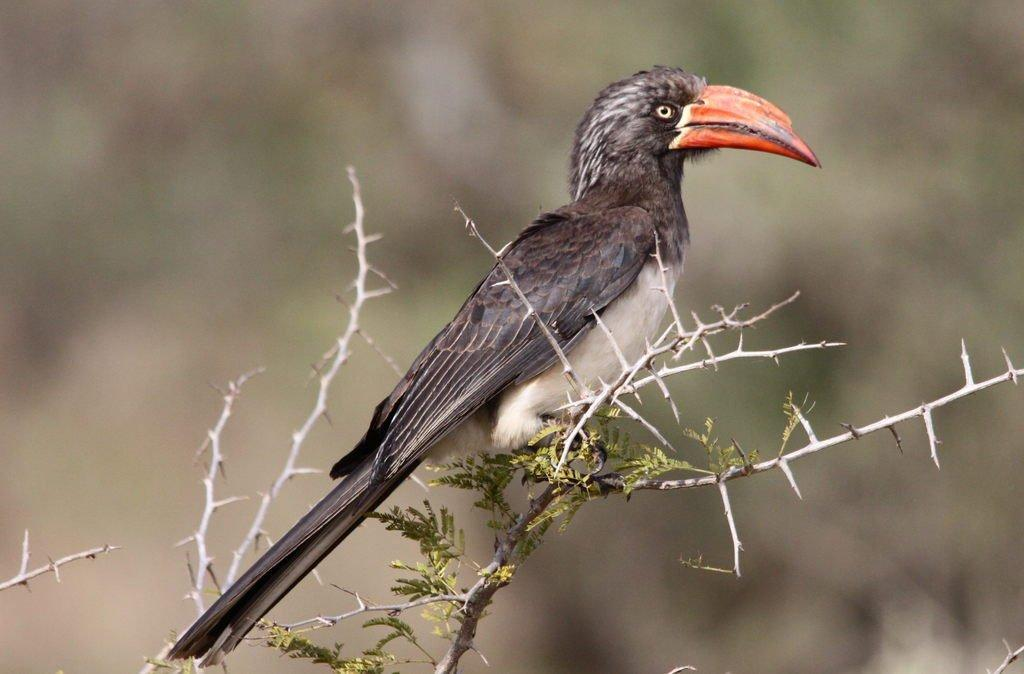What type of animal is in the image? There is a bird in the image, specifically a Hornbill. What is the Hornbill standing on? The Hornbill is standing on a stem. What else can be seen in the image besides the bird? There are leaves in the image. How would you describe the background of the image? The background of the image appears blurry. What type of apparatus is the bird using to fly in the image? There is no apparatus present in the image; the bird is standing on a stem. What type of beef is being served in the image? There is no beef present in the image; it features a Hornbill standing on a stem. 